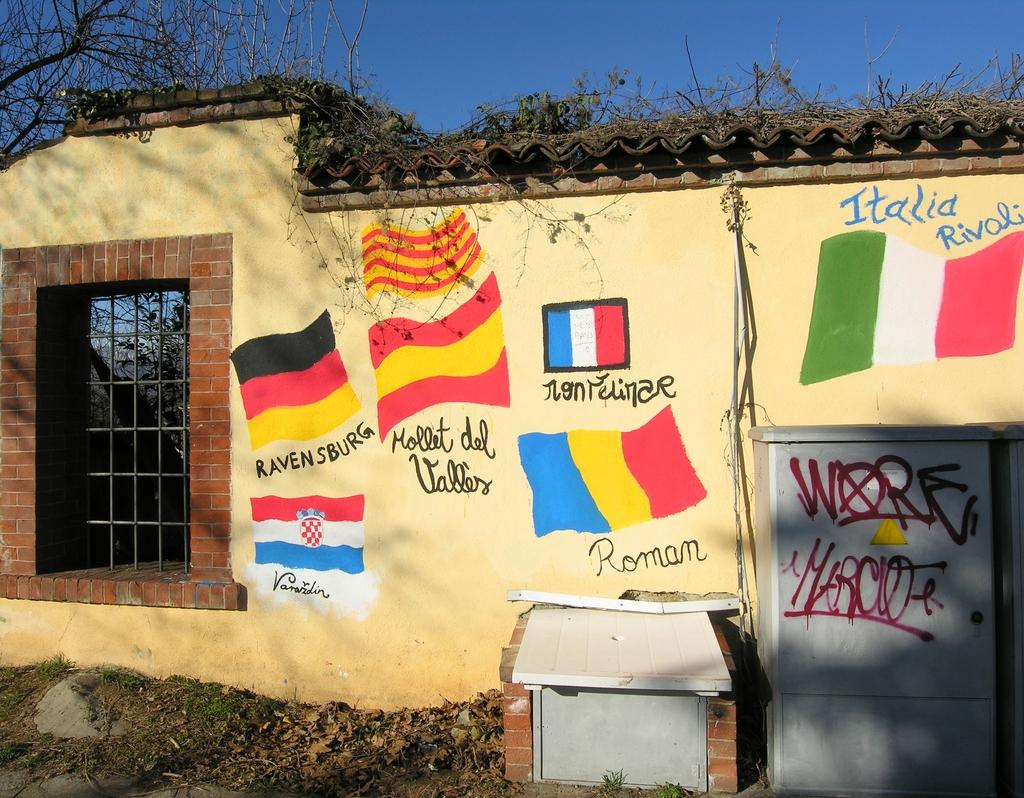What is hanging on the wall in the image? There are different flags on the wall. What can be seen on the left side of the image? There is an iron grill on the left side. How many sheep are present in the image? There are no sheep present in the image. What is the comparison between the flags and the iron grill in the image? The provided facts do not allow for a comparison between the flags and the iron grill, as they are separate subjects in the image. 